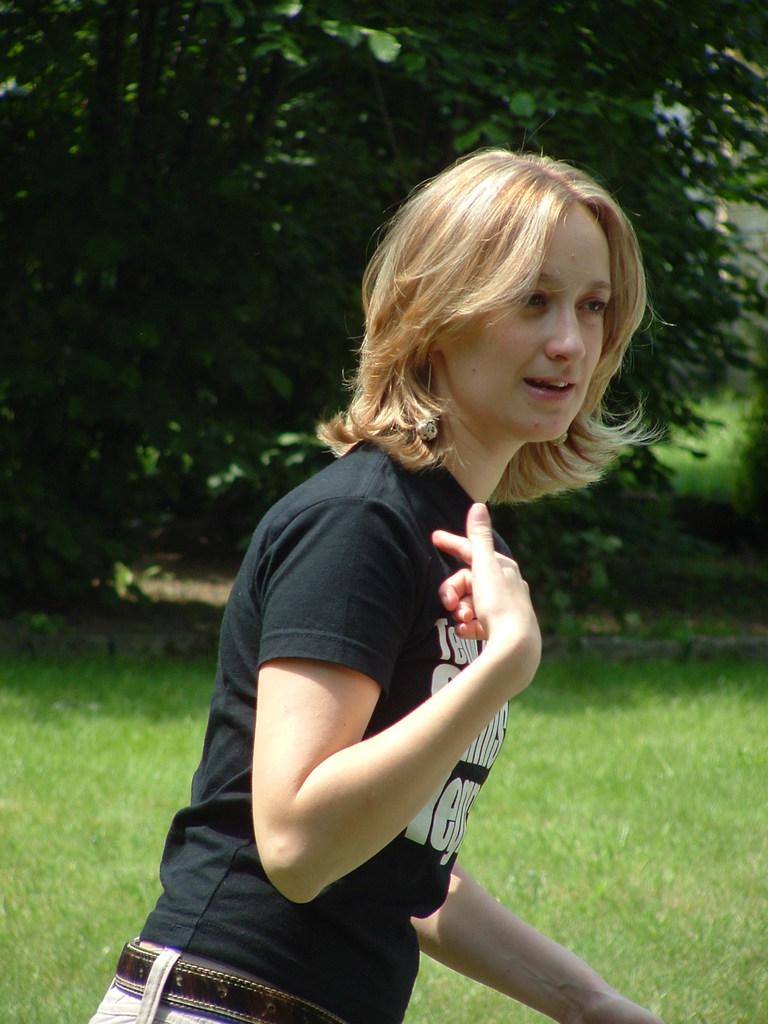Who is the main subject in the image? There is a girl in the image. What is the girl doing in the image? The girl is standing on the surface of the grass. What can be seen in the background of the image? There are trees in the background of the image. Can you see the girl's father in the image? There is no mention of the girl's father in the image, so we cannot confirm his presence. 